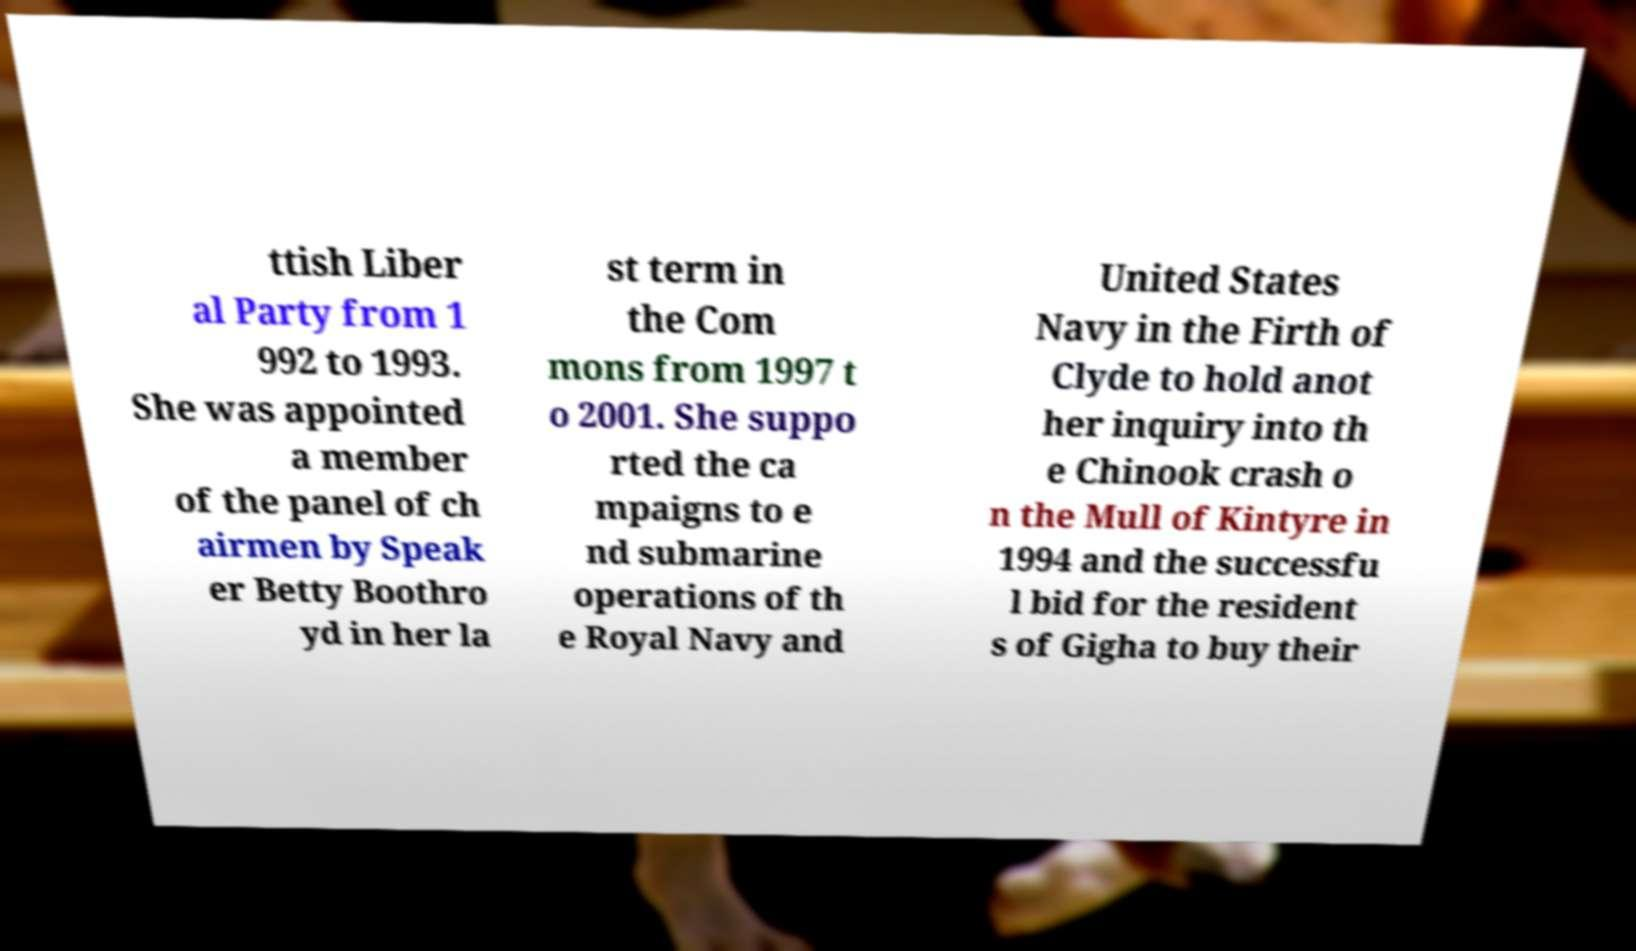I need the written content from this picture converted into text. Can you do that? ttish Liber al Party from 1 992 to 1993. She was appointed a member of the panel of ch airmen by Speak er Betty Boothro yd in her la st term in the Com mons from 1997 t o 2001. She suppo rted the ca mpaigns to e nd submarine operations of th e Royal Navy and United States Navy in the Firth of Clyde to hold anot her inquiry into th e Chinook crash o n the Mull of Kintyre in 1994 and the successfu l bid for the resident s of Gigha to buy their 